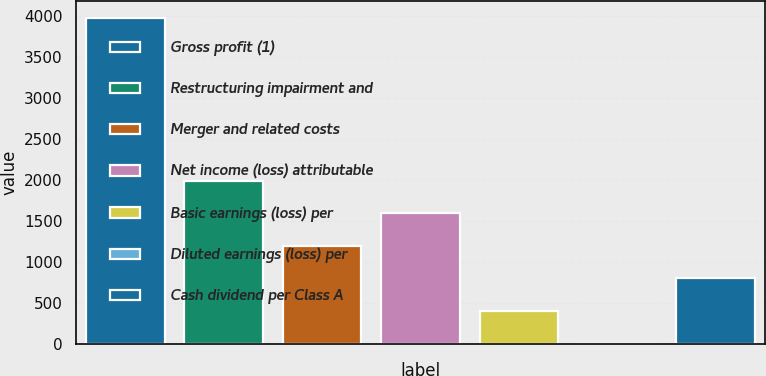<chart> <loc_0><loc_0><loc_500><loc_500><bar_chart><fcel>Gross profit (1)<fcel>Restructuring impairment and<fcel>Merger and related costs<fcel>Net income (loss) attributable<fcel>Basic earnings (loss) per<fcel>Diluted earnings (loss) per<fcel>Cash dividend per Class A<nl><fcel>3986<fcel>1993.23<fcel>1196.12<fcel>1594.67<fcel>399.01<fcel>0.45<fcel>797.57<nl></chart> 